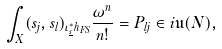<formula> <loc_0><loc_0><loc_500><loc_500>\int _ { X } ( s _ { j } , s _ { l } ) _ { \iota _ { \underline { s } } ^ { * } h _ { F S } } \frac { \omega ^ { n } } { n ! } = P _ { l j } \in i \mathfrak { u } ( N ) ,</formula> 